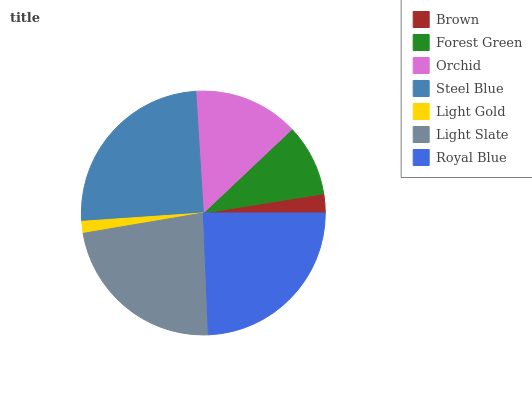Is Light Gold the minimum?
Answer yes or no. Yes. Is Steel Blue the maximum?
Answer yes or no. Yes. Is Forest Green the minimum?
Answer yes or no. No. Is Forest Green the maximum?
Answer yes or no. No. Is Forest Green greater than Brown?
Answer yes or no. Yes. Is Brown less than Forest Green?
Answer yes or no. Yes. Is Brown greater than Forest Green?
Answer yes or no. No. Is Forest Green less than Brown?
Answer yes or no. No. Is Orchid the high median?
Answer yes or no. Yes. Is Orchid the low median?
Answer yes or no. Yes. Is Brown the high median?
Answer yes or no. No. Is Forest Green the low median?
Answer yes or no. No. 